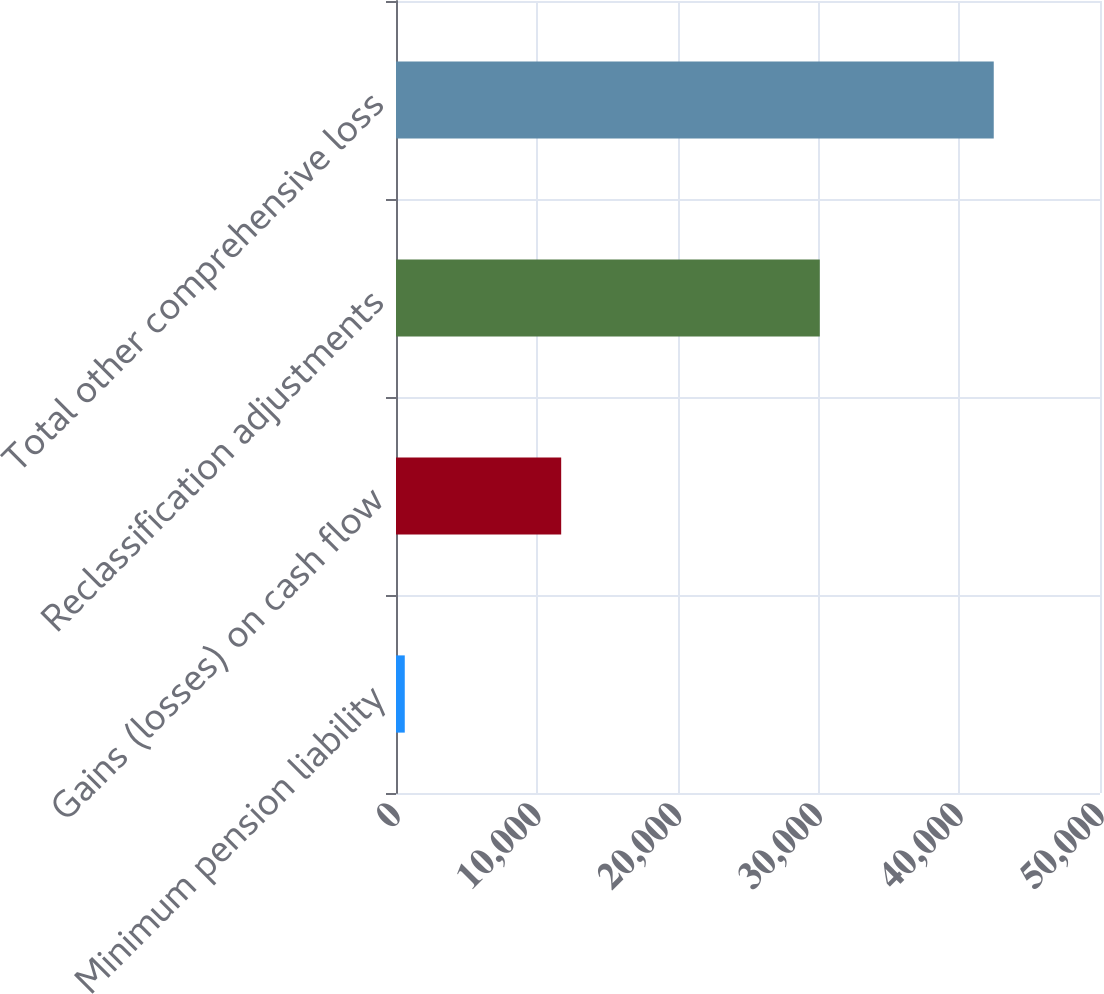<chart> <loc_0><loc_0><loc_500><loc_500><bar_chart><fcel>Minimum pension liability<fcel>Gains (losses) on cash flow<fcel>Reclassification adjustments<fcel>Total other comprehensive loss<nl><fcel>623<fcel>11732<fcel>30099<fcel>42454<nl></chart> 